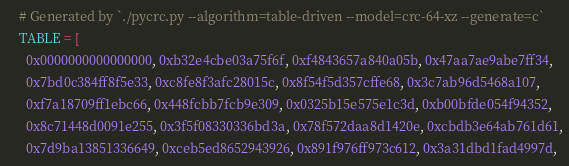Convert code to text. <code><loc_0><loc_0><loc_500><loc_500><_Crystal_>    # Generated by `./pycrc.py --algorithm=table-driven --model=crc-64-xz --generate=c`
    TABLE = [
      0x0000000000000000, 0xb32e4cbe03a75f6f, 0xf4843657a840a05b, 0x47aa7ae9abe7ff34,
      0x7bd0c384ff8f5e33, 0xc8fe8f3afc28015c, 0x8f54f5d357cffe68, 0x3c7ab96d5468a107,
      0xf7a18709ff1ebc66, 0x448fcbb7fcb9e309, 0x0325b15e575e1c3d, 0xb00bfde054f94352,
      0x8c71448d0091e255, 0x3f5f08330336bd3a, 0x78f572daa8d1420e, 0xcbdb3e64ab761d61,
      0x7d9ba13851336649, 0xceb5ed8652943926, 0x891f976ff973c612, 0x3a31dbd1fad4997d,</code> 